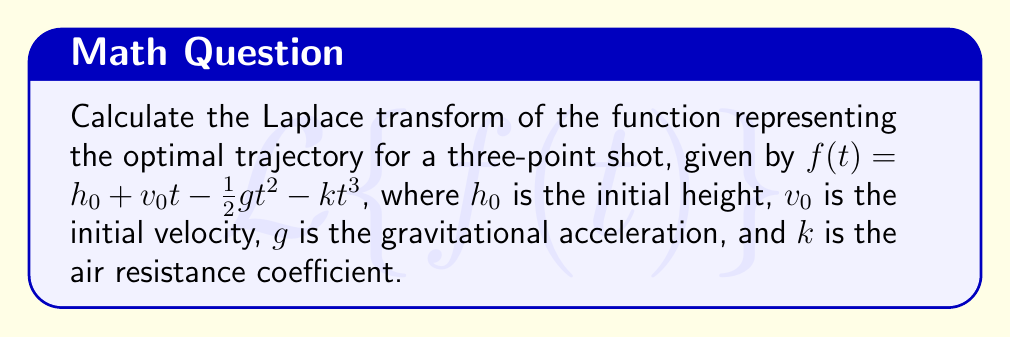Solve this math problem. To solve this problem, we need to apply the Laplace transform to the given function. Let's break it down step by step:

1) The Laplace transform of $f(t)$ is defined as:
   $$F(s) = \mathcal{L}\{f(t)\} = \int_0^\infty e^{-st}f(t)dt$$

2) We need to find the Laplace transform of each term in $f(t)$ separately:

   a) For the constant term $h_0$:
      $$\mathcal{L}\{h_0\} = \frac{h_0}{s}$$

   b) For the linear term $v_0t$:
      $$\mathcal{L}\{v_0t\} = \frac{v_0}{s^2}$$

   c) For the quadratic term $-\frac{1}{2}gt^2$:
      $$\mathcal{L}\{-\frac{1}{2}gt^2\} = -\frac{g}{s^3}$$

   d) For the cubic term $-kt^3$:
      $$\mathcal{L}\{-kt^3\} = -\frac{6k}{s^4}$$

3) Now, we can combine these results to get the Laplace transform of $f(t)$:

   $$F(s) = \frac{h_0}{s} + \frac{v_0}{s^2} - \frac{g}{s^3} - \frac{6k}{s^4}$$

4) This can be written as a single fraction:

   $$F(s) = \frac{h_0s^3 + v_0s^2 - gs - 6k}{s^4}$$

This is the Laplace transform of the function representing the optimal trajectory for a three-point shot, considering air resistance.
Answer: $$F(s) = \frac{h_0s^3 + v_0s^2 - gs - 6k}{s^4}$$ 